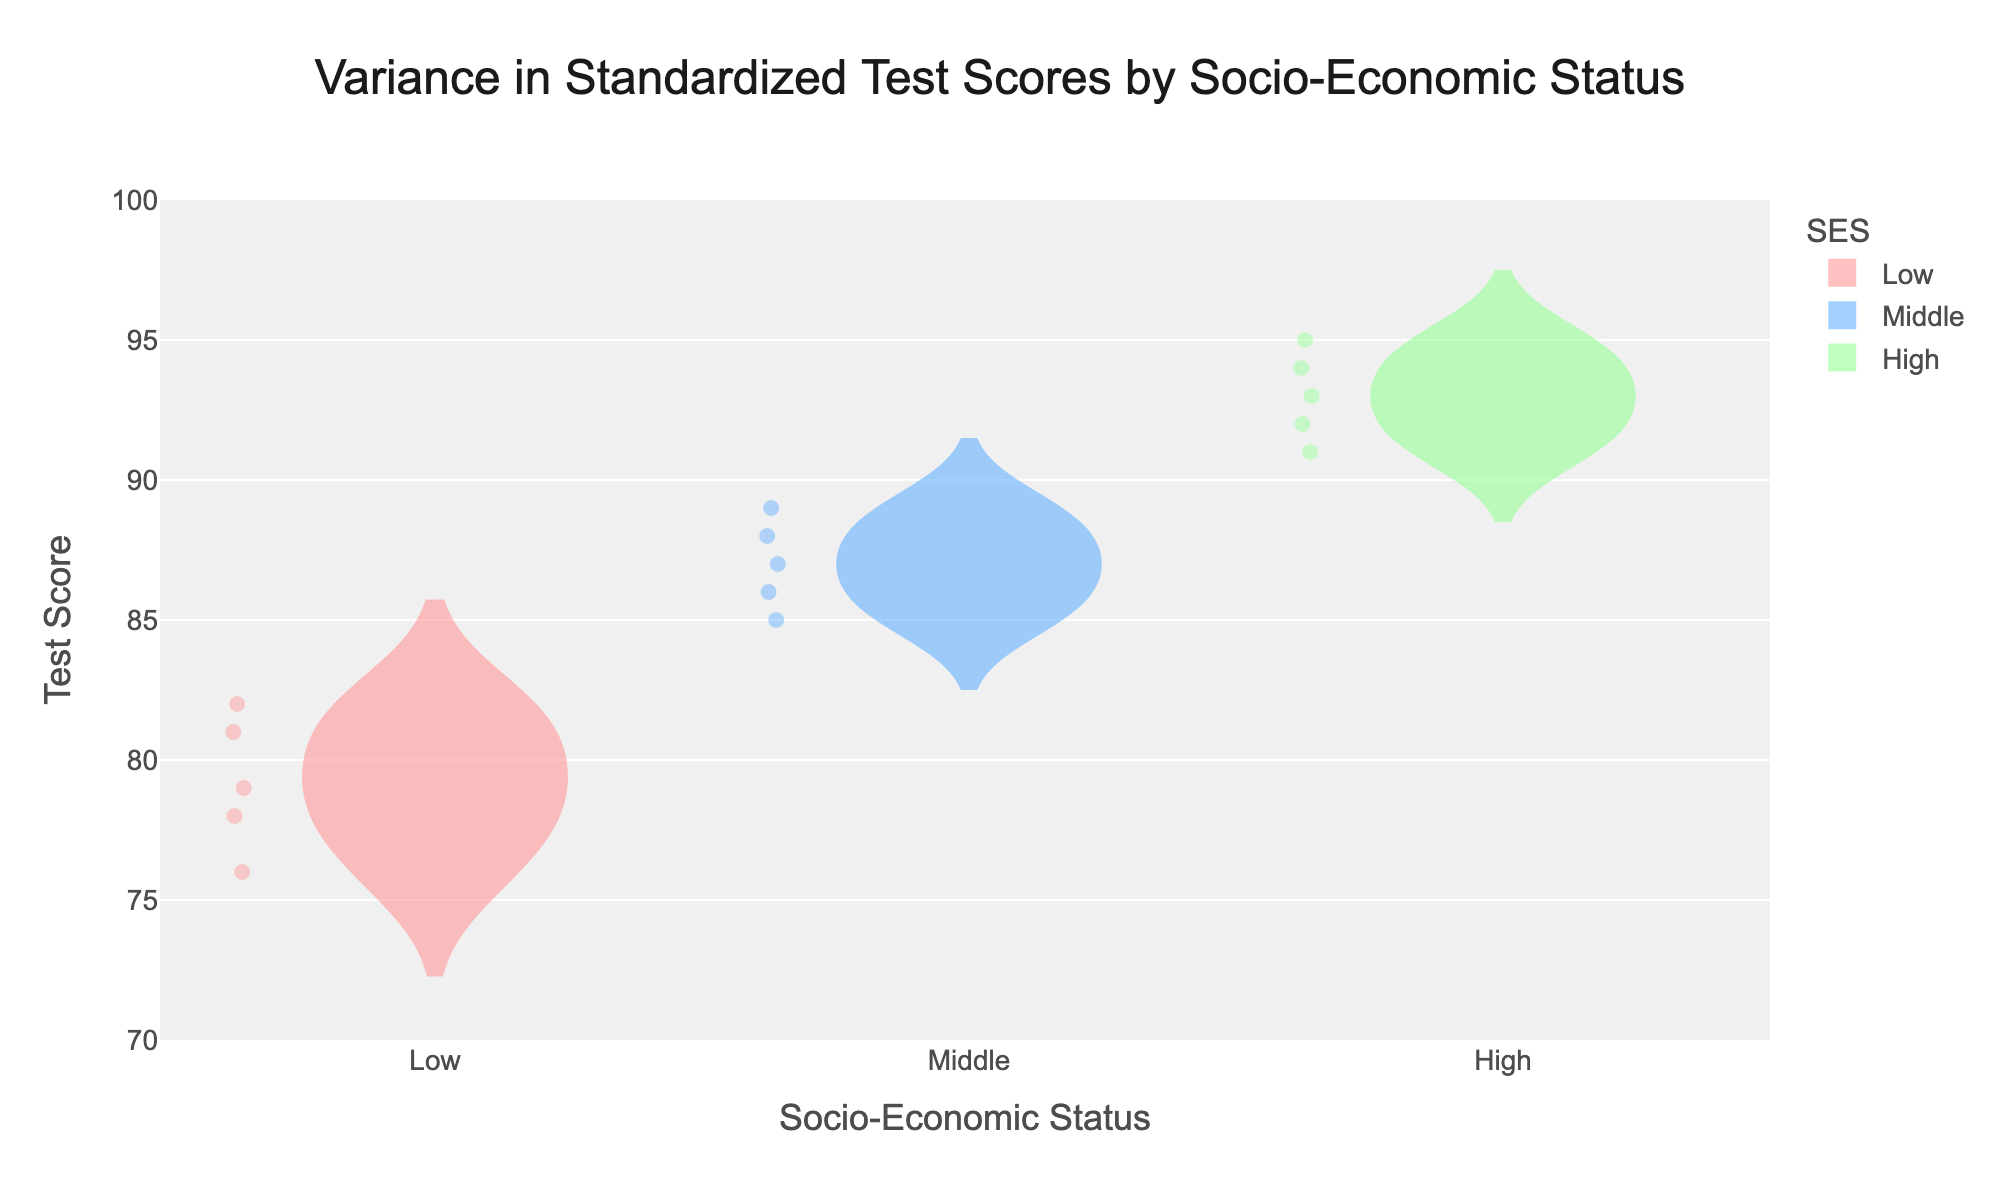What is the title of the chart? The title is displayed prominently at the top of the figure. It reads "Variance in Standardized Test Scores by Socio-Economic Status".
Answer: Variance in Standardized Test Scores by Socio-Economic Status Which socio-economic status group has the highest median score? The median score can be identified by the horizontal line in the center of the box plot. For the High socio-economic status group, this line is at a higher score compared to the Low and Middle groups.
Answer: High What is the test score range (min to max) for the Low socio-economic status group? The range is depicted by the bottom and top whiskers of the box plot for the Low SES group. The lowest point is 76, and the highest point is 82.
Answer: 76 to 82 Compare the median scores between the Middle and Low socio-economic status groups. Which is higher and by how much? The median score for Middle SES is represented by the middle line of its box plot at approximately 87. For Low SES, the median is around 79. The median score for Middle SES is higher by 87 - 79 = 8 points.
Answer: Middle SES by 8 points What is the distribution shape for the High socio-economic status group? The shape of the distribution can be seen from the spread and symmetry of the violin plot. The High SES group has a wider and more symmetric distribution compared to the other groups, indicating a more uniform distribution of scores within a high range.
Answer: Symmetric How many students are in each of the socio-economic status groups? The number of data points represented by markers can be counted for each group. There are 5 students in each group (Low, Middle, and High).
Answer: 5 per group Which socio-economic status group has the smallest interquartile range (IQR)? The IQR is the range between the first quartile (bottom of the box) and the third quartile (top of the box). For the Low SES group, this range is smaller compared to Middle and High SES groups.
Answer: Low What can be inferred about the mean score for the High socio-economic status group compared to the other groups? The mean score is depicted by the dashed line within the violin plot. For the High SES group, the mean is higher than both the Low and Middle SES groups.
Answer: Higher Are there any outliers in the Low socio-economic status group? Outliers would typically be indicated by points that fall outside the whiskers of the box plot. There are no such points for the Low SES group.
Answer: No Explain the significance of the violin plots being wider at certain parts for different groups. The width of the violin plot at different parts represents the density of scores. A wider section indicates a higher concentration of students with scores in that range. For example, the High SES group is wide at the top, showing many students scored high.
Answer: Indicates score density 